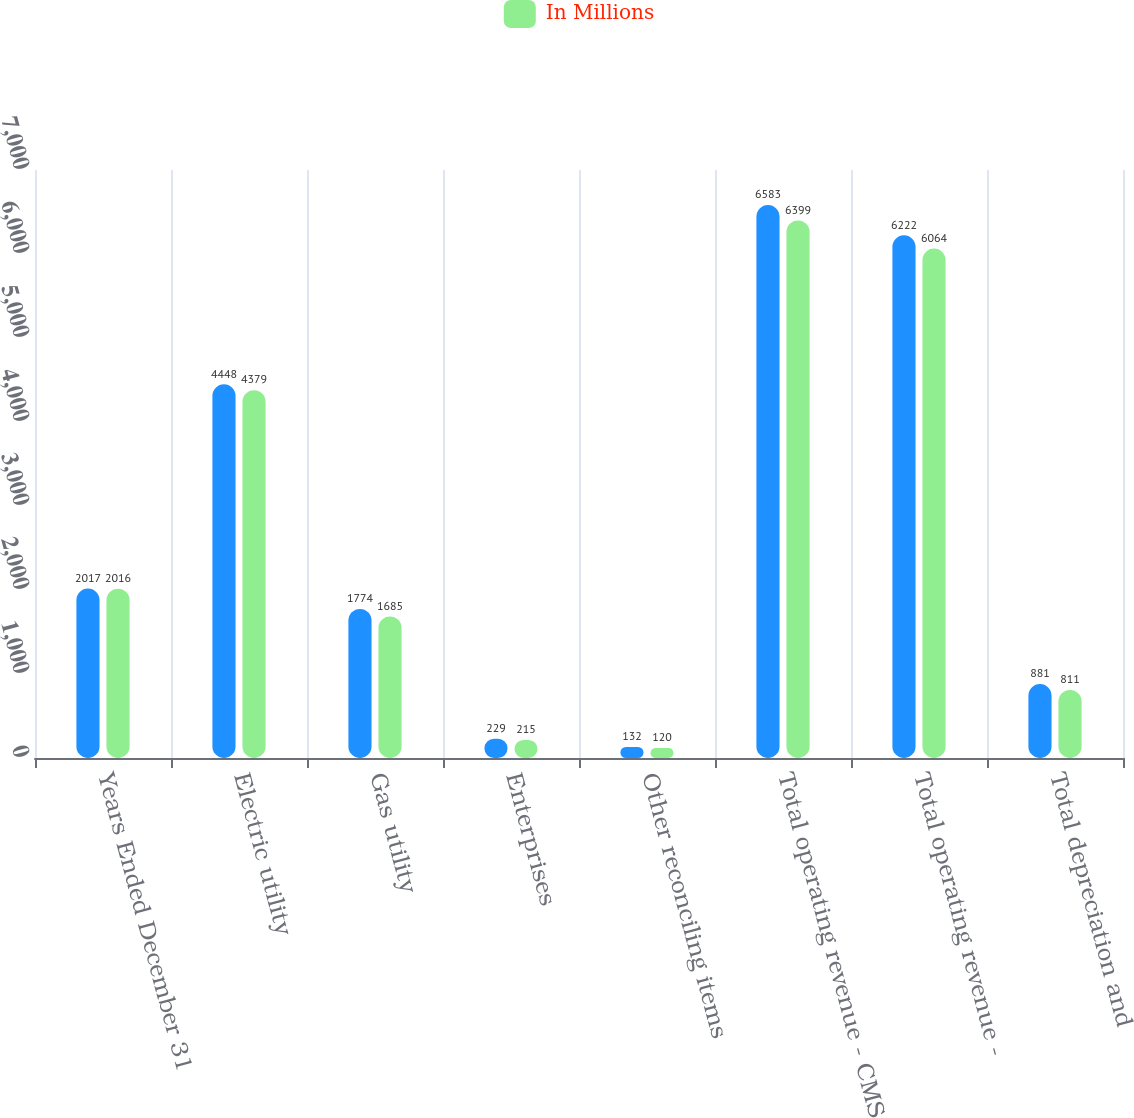Convert chart. <chart><loc_0><loc_0><loc_500><loc_500><stacked_bar_chart><ecel><fcel>Years Ended December 31<fcel>Electric utility<fcel>Gas utility<fcel>Enterprises<fcel>Other reconciling items<fcel>Total operating revenue - CMS<fcel>Total operating revenue -<fcel>Total depreciation and<nl><fcel>nan<fcel>2017<fcel>4448<fcel>1774<fcel>229<fcel>132<fcel>6583<fcel>6222<fcel>881<nl><fcel>In Millions<fcel>2016<fcel>4379<fcel>1685<fcel>215<fcel>120<fcel>6399<fcel>6064<fcel>811<nl></chart> 